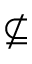Convert formula to latex. <formula><loc_0><loc_0><loc_500><loc_500>\nsubseteq</formula> 